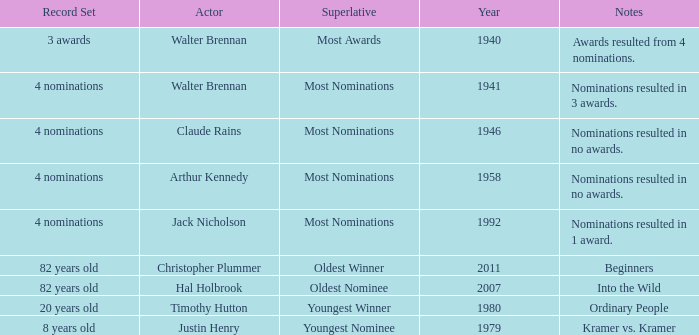What is the earliest year for ordinary people to appear in the notes? 1980.0. 